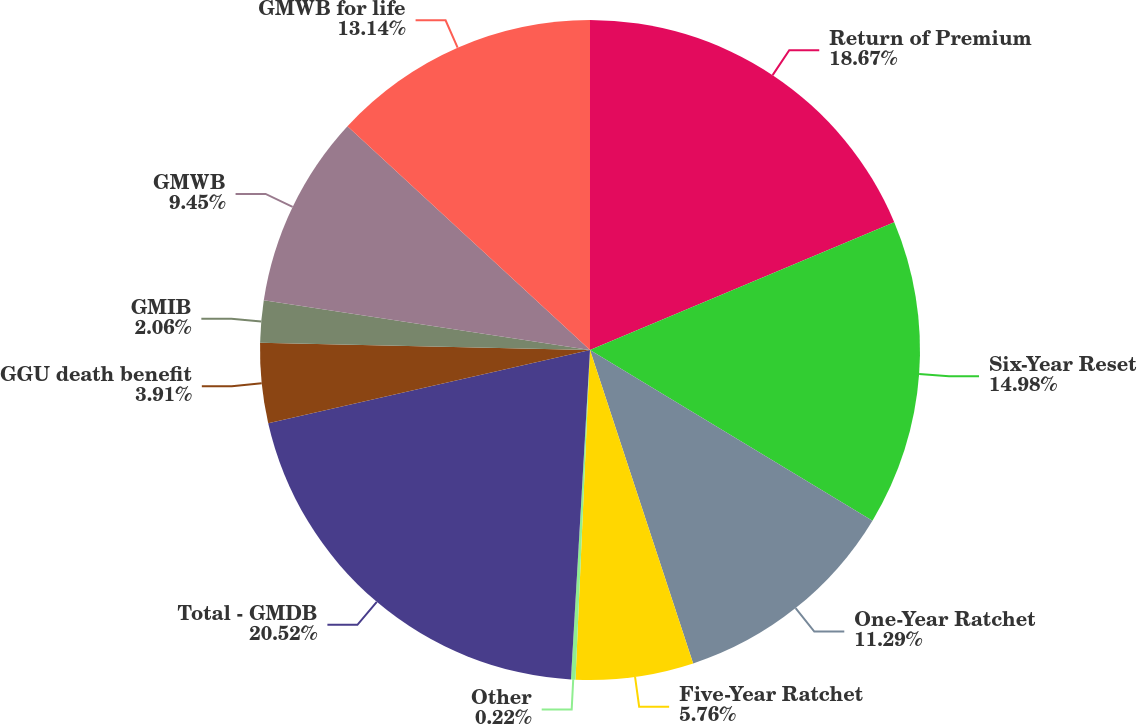<chart> <loc_0><loc_0><loc_500><loc_500><pie_chart><fcel>Return of Premium<fcel>Six-Year Reset<fcel>One-Year Ratchet<fcel>Five-Year Ratchet<fcel>Other<fcel>Total - GMDB<fcel>GGU death benefit<fcel>GMIB<fcel>GMWB<fcel>GMWB for life<nl><fcel>18.67%<fcel>14.98%<fcel>11.29%<fcel>5.76%<fcel>0.22%<fcel>20.52%<fcel>3.91%<fcel>2.06%<fcel>9.45%<fcel>13.14%<nl></chart> 